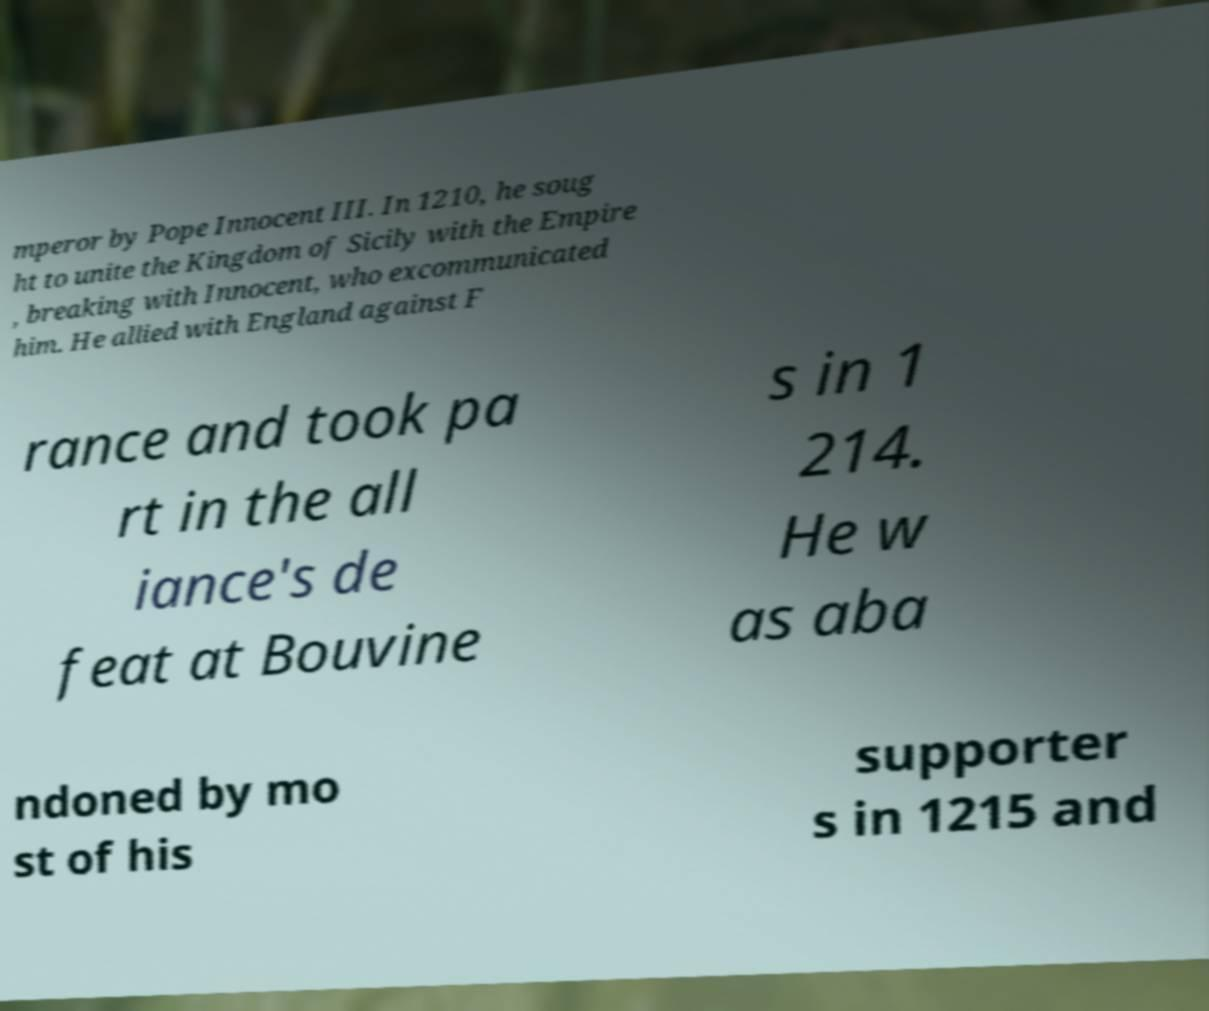Please identify and transcribe the text found in this image. mperor by Pope Innocent III. In 1210, he soug ht to unite the Kingdom of Sicily with the Empire , breaking with Innocent, who excommunicated him. He allied with England against F rance and took pa rt in the all iance's de feat at Bouvine s in 1 214. He w as aba ndoned by mo st of his supporter s in 1215 and 